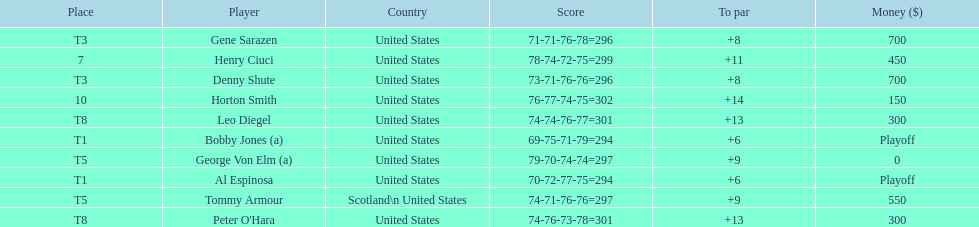What was al espinosa's total stroke count at the final of the 1929 us open? 294. 